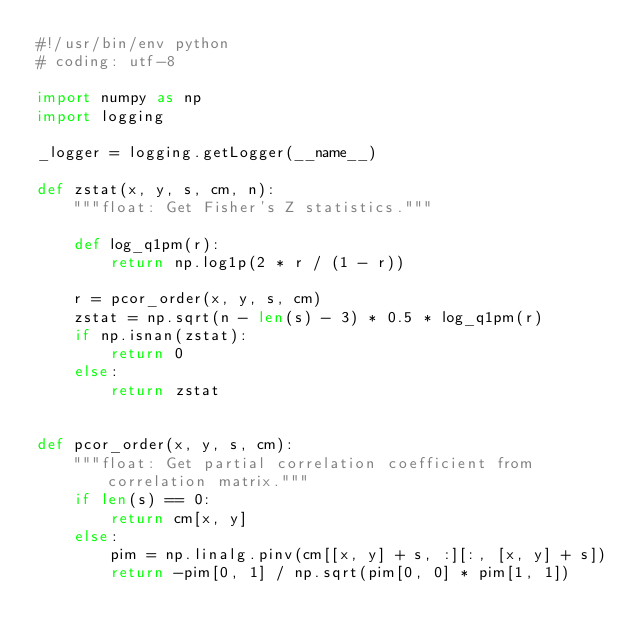<code> <loc_0><loc_0><loc_500><loc_500><_Python_>#!/usr/bin/env python
# coding: utf-8

import numpy as np
import logging

_logger = logging.getLogger(__name__)

def zstat(x, y, s, cm, n):
    """float: Get Fisher's Z statistics."""
 
    def log_q1pm(r):
        return np.log1p(2 * r / (1 - r))

    r = pcor_order(x, y, s, cm)
    zstat = np.sqrt(n - len(s) - 3) * 0.5 * log_q1pm(r)
    if np.isnan(zstat):
        return 0
    else:
        return zstat


def pcor_order(x, y, s, cm):
    """float: Get partial correlation coefficient from correlation matrix."""
    if len(s) == 0:
        return cm[x, y]
    else:
        pim = np.linalg.pinv(cm[[x, y] + s, :][:, [x, y] + s])
        return -pim[0, 1] / np.sqrt(pim[0, 0] * pim[1, 1])


</code> 